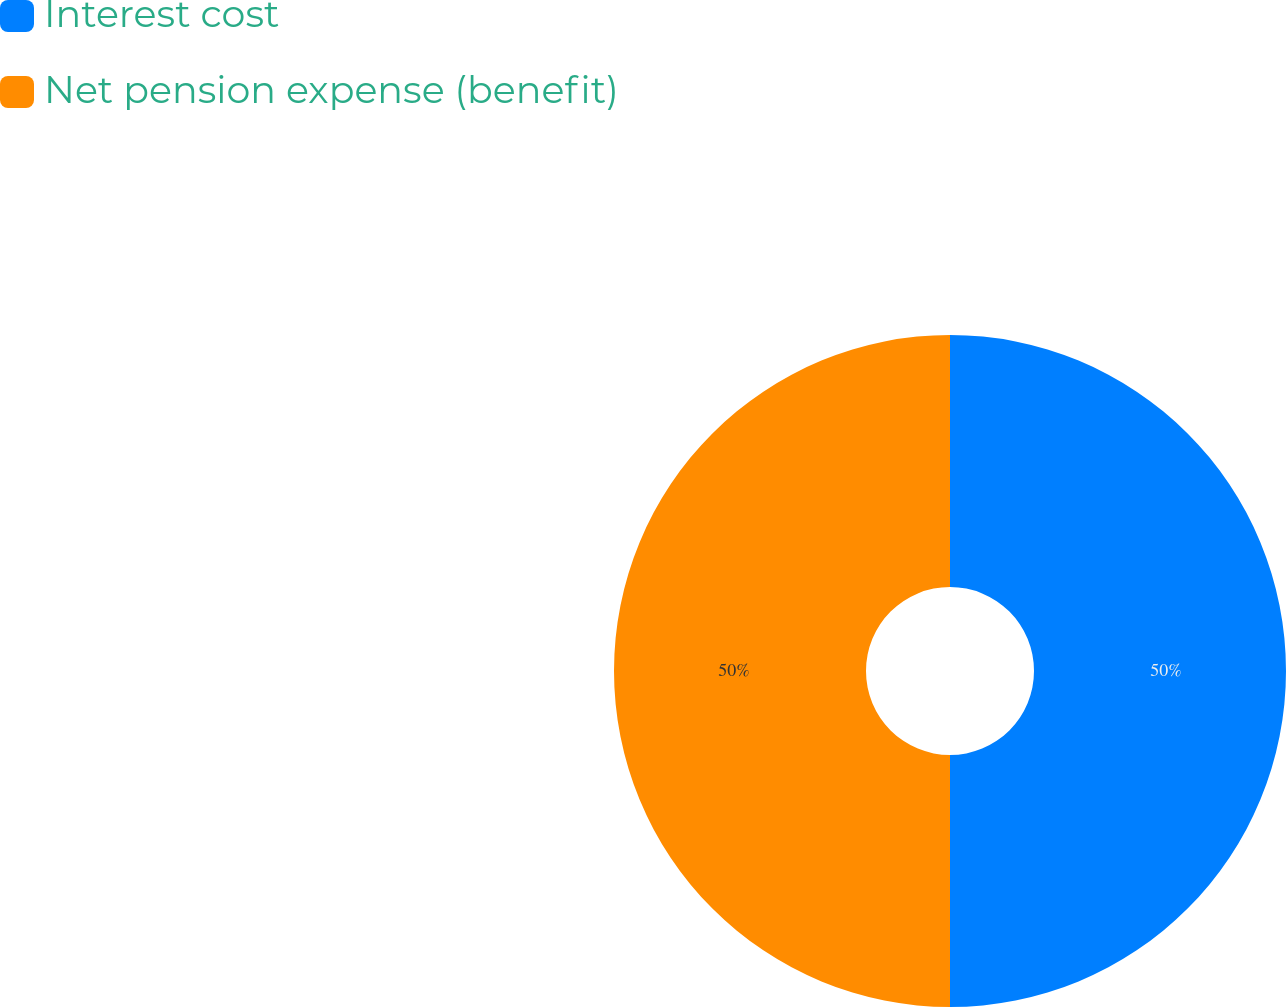<chart> <loc_0><loc_0><loc_500><loc_500><pie_chart><fcel>Interest cost<fcel>Net pension expense (benefit)<nl><fcel>50.0%<fcel>50.0%<nl></chart> 